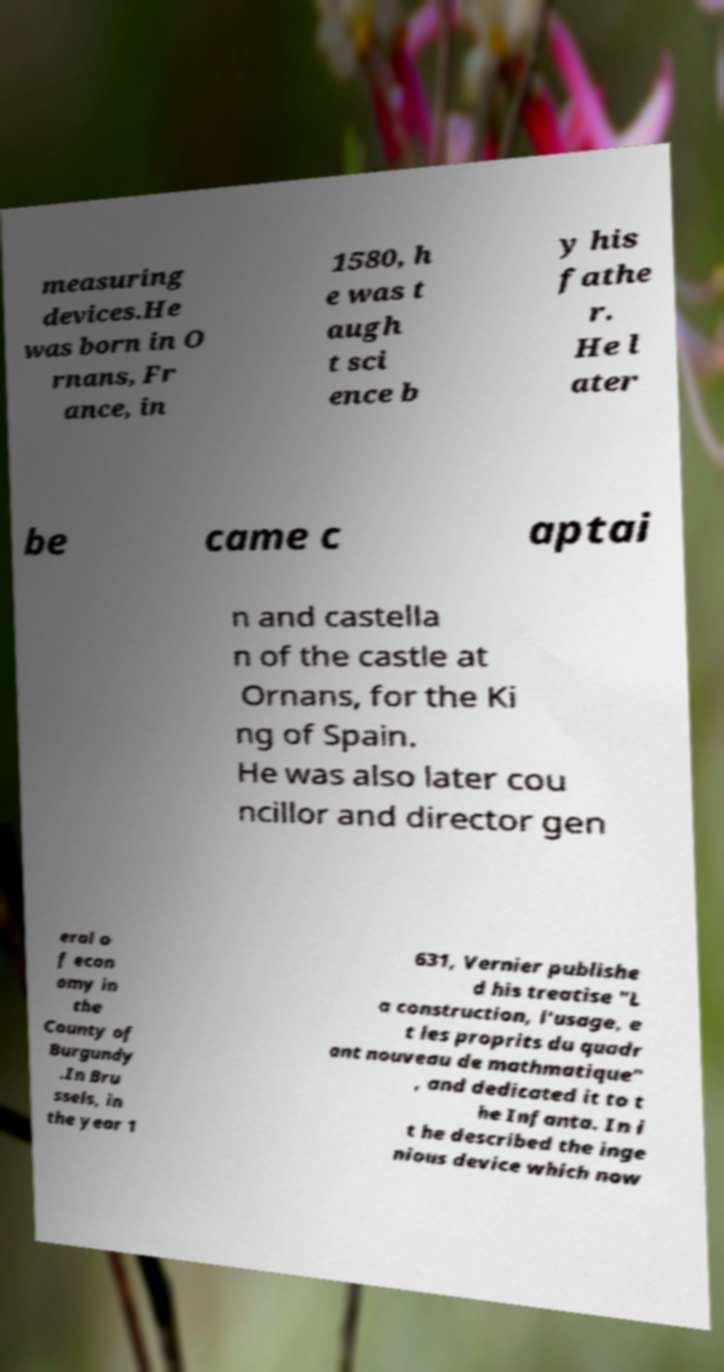Please identify and transcribe the text found in this image. measuring devices.He was born in O rnans, Fr ance, in 1580, h e was t augh t sci ence b y his fathe r. He l ater be came c aptai n and castella n of the castle at Ornans, for the Ki ng of Spain. He was also later cou ncillor and director gen eral o f econ omy in the County of Burgundy .In Bru ssels, in the year 1 631, Vernier publishe d his treatise "L a construction, l'usage, e t les proprits du quadr ant nouveau de mathmatique" , and dedicated it to t he Infanta. In i t he described the inge nious device which now 